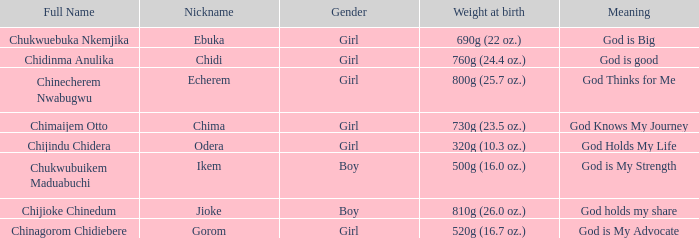I'm looking to parse the entire table for insights. Could you assist me with that? {'header': ['Full Name', 'Nickname', 'Gender', 'Weight at birth', 'Meaning'], 'rows': [['Chukwuebuka Nkemjika', 'Ebuka', 'Girl', '690g (22 oz.)', 'God is Big'], ['Chidinma Anulika', 'Chidi', 'Girl', '760g (24.4 oz.)', 'God is good'], ['Chinecherem Nwabugwu', 'Echerem', 'Girl', '800g (25.7 oz.)', 'God Thinks for Me'], ['Chimaijem Otto', 'Chima', 'Girl', '730g (23.5 oz.)', 'God Knows My Journey'], ['Chijindu Chidera', 'Odera', 'Girl', '320g (10.3 oz.)', 'God Holds My Life'], ['Chukwubuikem Maduabuchi', 'Ikem', 'Boy', '500g (16.0 oz.)', 'God is My Strength'], ['Chijioke Chinedum', 'Jioke', 'Boy', '810g (26.0 oz.)', 'God holds my share'], ['Chinagorom Chidiebere', 'Gorom', 'Girl', '520g (16.7 oz.)', 'God is My Advocate']]} What is the nickname of the boy who weighed 810g (26.0 oz.) at birth? Jioke. 